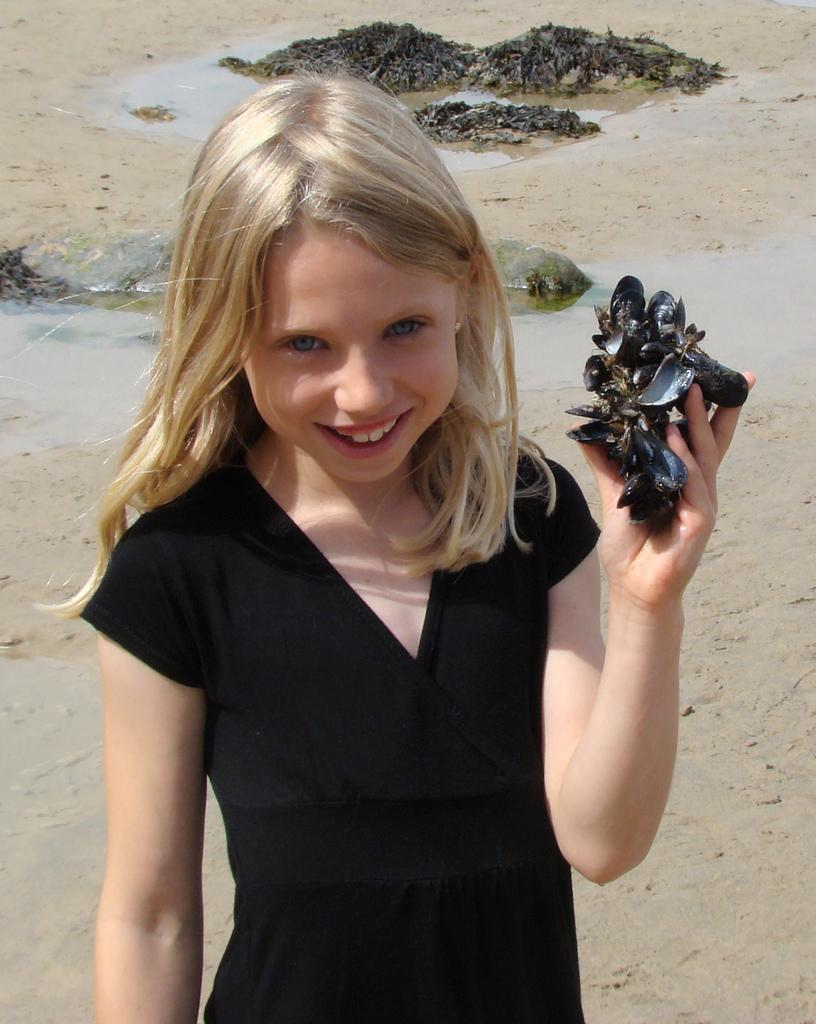What is the main subject of the image? There is a child in the image. What is the child doing in the image? The child is standing on the ground and holding something in her hand. How is the child feeling in the image? The child is smiling in the image. What can be seen in the background of the image? There is water visible in the background of the image. How many ducks are balancing on the wire in the image? There are no ducks or wires present in the image. 